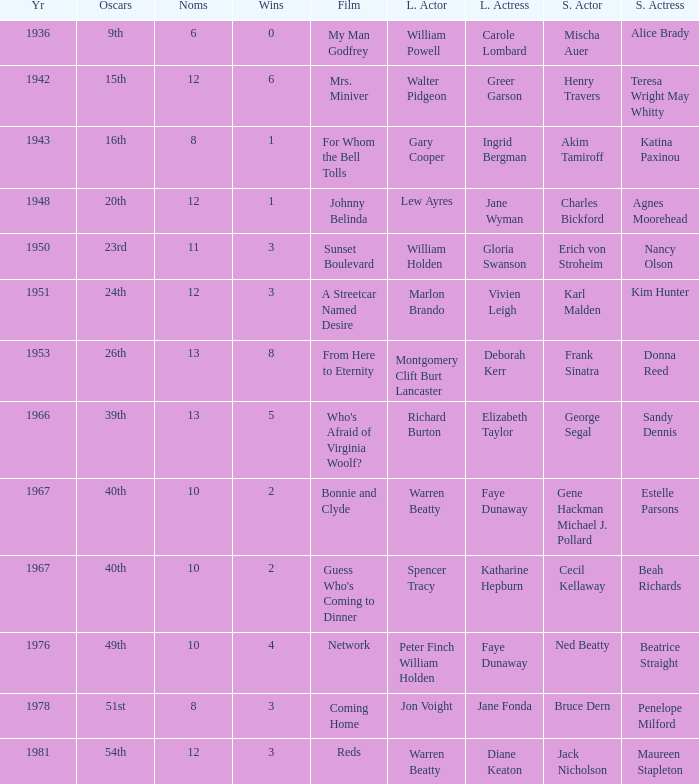Who was the supporting actress in "For Whom the Bell Tolls"? Katina Paxinou. 